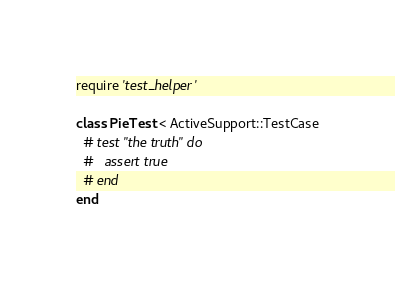<code> <loc_0><loc_0><loc_500><loc_500><_Ruby_>require 'test_helper'

class PieTest < ActiveSupport::TestCase
  # test "the truth" do
  #   assert true
  # end
end
</code> 